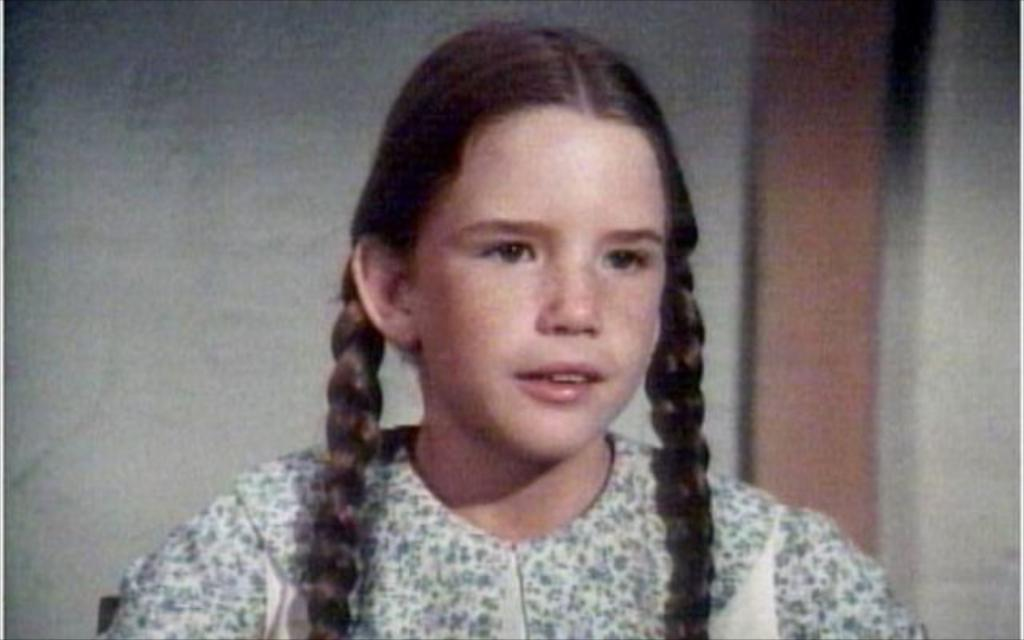Who is the main subject in the picture? There is a girl in the picture. Can you describe the girl's hairstyle? The girl has two plait hairs. What can be seen in the background of the picture? There is a wall in the background of the picture. What time does the alarm go off in the picture? There is no alarm present in the picture. What is the name of the girl in the picture? The name of the girl is not mentioned in the picture. 